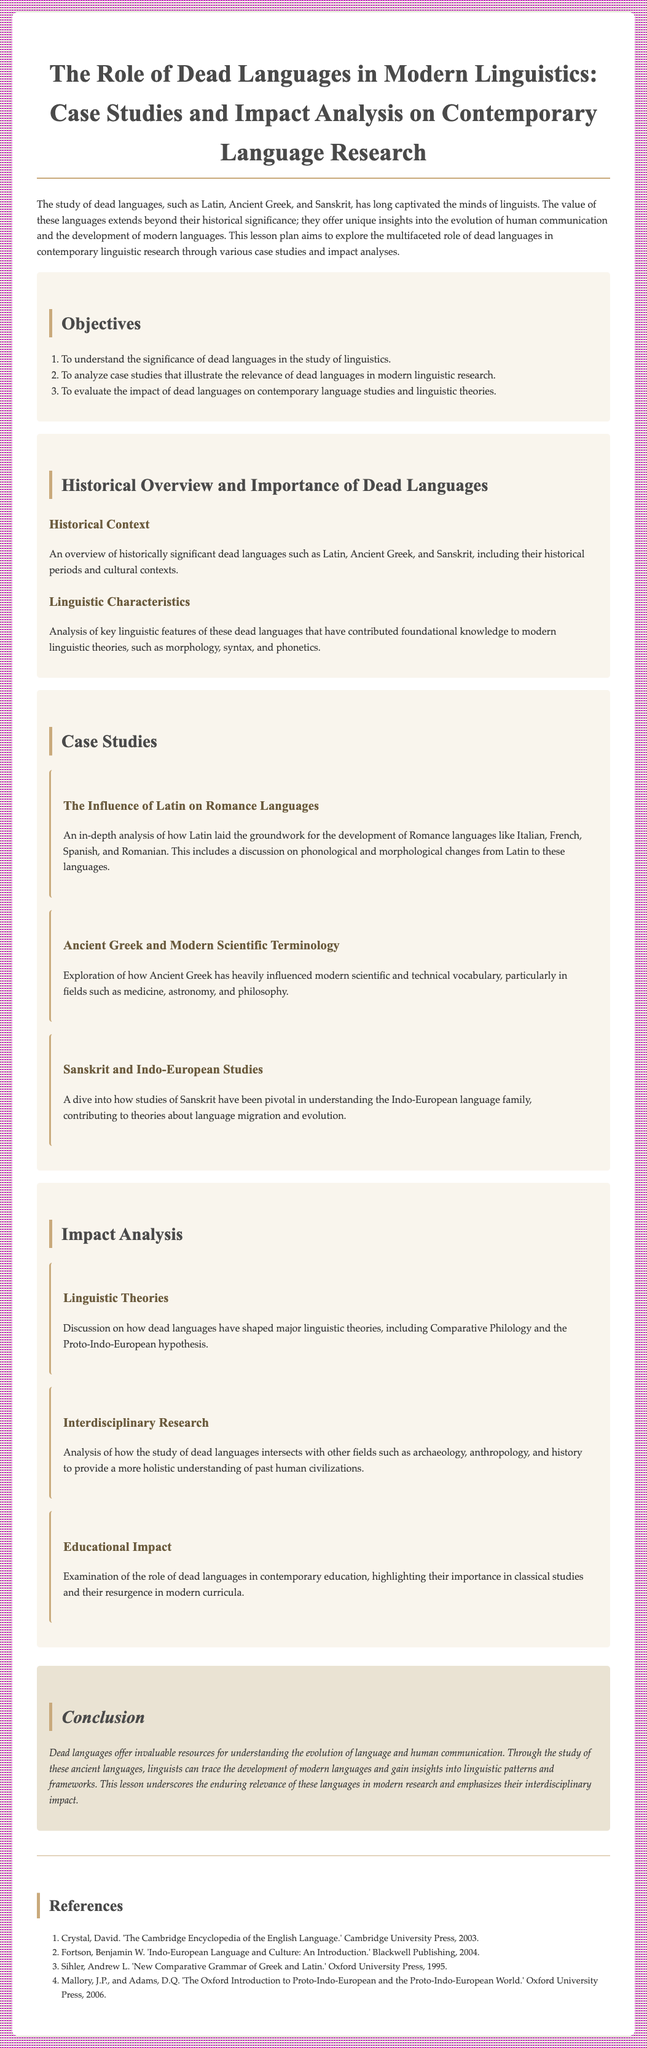what are the three objectives outlined in the lesson plan? The objectives listed in the lesson plan provide a framework for studying dead languages and include understanding their significance, analyzing case studies, and evaluating their impact on contemporary studies.
Answer: understanding the significance, analyzing case studies, evaluating the impact which dead languages are specifically mentioned in the historical overview? The document lists Latin, Ancient Greek, and Sanskrit in the historical overview section.
Answer: Latin, Ancient Greek, Sanskrit what is the first case study discussed? The document provides three case studies, the first of which focuses on how Latin influenced Romance languages.
Answer: The Influence of Latin on Romance Languages how does the study of dead languages intersect with other fields? The impact analysis section discusses how dead languages relate to various fields such as archaeology and history to give a comprehensive understanding of civilizations.
Answer: archaeology, anthropology, history how many references are listed in the document? The references section enumerates the sources cited in the lesson plan, which totals four entries.
Answer: four 